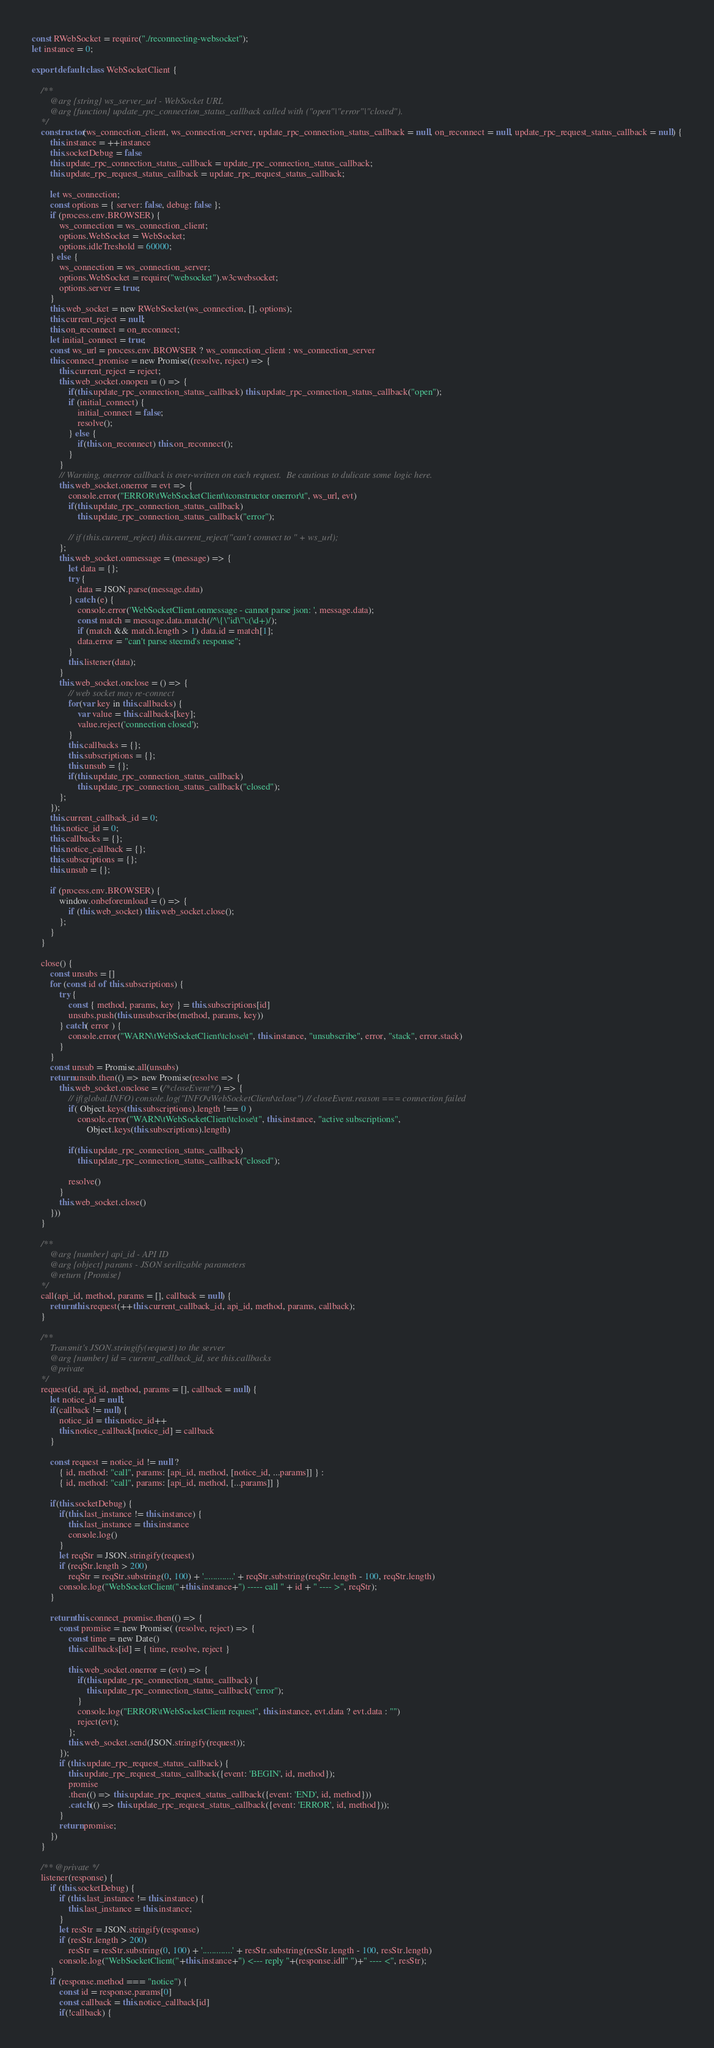<code> <loc_0><loc_0><loc_500><loc_500><_JavaScript_>const RWebSocket = require("./reconnecting-websocket");
let instance = 0;

export default class WebSocketClient {

    /**
        @arg {string} ws_server_url - WebSocket URL
        @arg {function} update_rpc_connection_status_callback called with ("open"|"error"|"closed").
    */
    constructor(ws_connection_client, ws_connection_server, update_rpc_connection_status_callback = null, on_reconnect = null, update_rpc_request_status_callback = null) {
        this.instance = ++instance
        this.socketDebug = false
        this.update_rpc_connection_status_callback = update_rpc_connection_status_callback;
        this.update_rpc_request_status_callback = update_rpc_request_status_callback;

        let ws_connection;
        const options = { server: false, debug: false };
        if (process.env.BROWSER) {
            ws_connection = ws_connection_client;
            options.WebSocket = WebSocket;
            options.idleTreshold = 60000;
        } else {
            ws_connection = ws_connection_server;
            options.WebSocket = require("websocket").w3cwebsocket;
            options.server = true;
        }
        this.web_socket = new RWebSocket(ws_connection, [], options);
        this.current_reject = null;
        this.on_reconnect = on_reconnect;
        let initial_connect = true;
        const ws_url = process.env.BROWSER ? ws_connection_client : ws_connection_server
        this.connect_promise = new Promise((resolve, reject) => {
            this.current_reject = reject;
            this.web_socket.onopen = () => {
                if(this.update_rpc_connection_status_callback) this.update_rpc_connection_status_callback("open");
                if (initial_connect) {
                    initial_connect = false;
                    resolve();
                } else {
                    if(this.on_reconnect) this.on_reconnect();
                }
            }
            // Warning, onerror callback is over-written on each request.  Be cautious to dulicate some logic here.
            this.web_socket.onerror = evt => {
                console.error("ERROR\tWebSocketClient\tconstructor onerror\t", ws_url, evt)
                if(this.update_rpc_connection_status_callback)
                    this.update_rpc_connection_status_callback("error");

                // if (this.current_reject) this.current_reject("can't connect to " + ws_url);
            };
            this.web_socket.onmessage = (message) => {
                let data = {};
                try {
                    data = JSON.parse(message.data)
                } catch (e) {
                    console.error('WebSocketClient.onmessage - cannot parse json: ', message.data);
                    const match = message.data.match(/^\{\"id\"\:(\d+)/);
                    if (match && match.length > 1) data.id = match[1];
                    data.error = "can't parse steemd's response";
                }
                this.listener(data);
            }
            this.web_socket.onclose = () => {
                // web socket may re-connect
                for(var key in this.callbacks) {
                    var value = this.callbacks[key];
                    value.reject('connection closed');
                }
                this.callbacks = {};
                this.subscriptions = {};
                this.unsub = {};
                if(this.update_rpc_connection_status_callback)
                    this.update_rpc_connection_status_callback("closed");
            };
        });
        this.current_callback_id = 0;
        this.notice_id = 0;
        this.callbacks = {};
        this.notice_callback = {};
        this.subscriptions = {};
        this.unsub = {};

        if (process.env.BROWSER) {
            window.onbeforeunload = () => {
                if (this.web_socket) this.web_socket.close();
            };
        }
    }

    close() {
        const unsubs = []
        for (const id of this.subscriptions) {
            try {
                const { method, params, key } = this.subscriptions[id]
                unsubs.push(this.unsubscribe(method, params, key))
            } catch( error ) {
                console.error("WARN\tWebSocketClient\tclose\t", this.instance, "unsubscribe", error, "stack", error.stack)
            }
        }
        const unsub = Promise.all(unsubs)
        return unsub.then(() => new Promise(resolve => {
            this.web_socket.onclose = (/*closeEvent*/) => {
                // if(global.INFO) console.log("INFO\tWebSocketClient\tclose") // closeEvent.reason === connection failed
                if( Object.keys(this.subscriptions).length !== 0 )
                    console.error("WARN\tWebSocketClient\tclose\t", this.instance, "active subscriptions",
                        Object.keys(this.subscriptions).length)

                if(this.update_rpc_connection_status_callback)
                    this.update_rpc_connection_status_callback("closed");

                resolve()
            }
            this.web_socket.close()
        }))
    }

    /**
        @arg {number} api_id - API ID
        @arg {object} params - JSON serilizable parameters
        @return {Promise}
    */
    call(api_id, method, params = [], callback = null) {
        return this.request(++this.current_callback_id, api_id, method, params, callback);
    }

    /**
        Transmit's JSON.stringify(request) to the server
        @arg {number} id = current_callback_id, see this.callbacks
        @private
    */
    request(id, api_id, method, params = [], callback = null) {
        let notice_id = null;
        if(callback != null) {
            notice_id = this.notice_id++
            this.notice_callback[notice_id] = callback
        }

        const request = notice_id != null ?
            { id, method: "call", params: [api_id, method, [notice_id, ...params]] } :
            { id, method: "call", params: [api_id, method, [...params]] }

        if(this.socketDebug) {
            if(this.last_instance != this.instance) {
                this.last_instance = this.instance
                console.log()
            }
            let reqStr = JSON.stringify(request)
            if (reqStr.length > 200)
                reqStr = reqStr.substring(0, 100) + '.............' + reqStr.substring(reqStr.length - 100, reqStr.length)
            console.log("WebSocketClient("+this.instance+") ----- call " + id + " ---- >", reqStr);
        }

        return this.connect_promise.then(() => {
            const promise = new Promise( (resolve, reject) => {
                const time = new Date()
                this.callbacks[id] = { time, resolve, reject }

                this.web_socket.onerror = (evt) => {
                    if(this.update_rpc_connection_status_callback) {
                        this.update_rpc_connection_status_callback("error");
                    }
                    console.log("ERROR\tWebSocketClient request", this.instance, evt.data ? evt.data : "")
                    reject(evt);
                };
                this.web_socket.send(JSON.stringify(request));
            });
            if (this.update_rpc_request_status_callback) {
                this.update_rpc_request_status_callback({event: 'BEGIN', id, method});
                promise
                .then(() => this.update_rpc_request_status_callback({event: 'END', id, method}))
                .catch(() => this.update_rpc_request_status_callback({event: 'ERROR', id, method}));
            }
            return promise;
        })
    }

    /** @private */
    listener(response) {
        if (this.socketDebug) {
            if (this.last_instance != this.instance) {
                this.last_instance = this.instance;
            }
            let resStr = JSON.stringify(response)
            if (resStr.length > 200)
                resStr = resStr.substring(0, 100) + '.............' + resStr.substring(resStr.length - 100, resStr.length)
            console.log("WebSocketClient("+this.instance+") <--- reply "+(response.id||" ")+" ---- <", resStr);
        }
        if (response.method === "notice") {
            const id = response.params[0]
            const callback = this.notice_callback[id]
            if(!callback) {</code> 